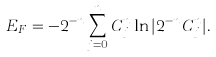<formula> <loc_0><loc_0><loc_500><loc_500>E _ { F } = - 2 ^ { - n } \sum ^ { n } _ { j = 0 } C ^ { n } _ { j } \ln | { 2 ^ { - n } C ^ { n } _ { j } } | .</formula> 